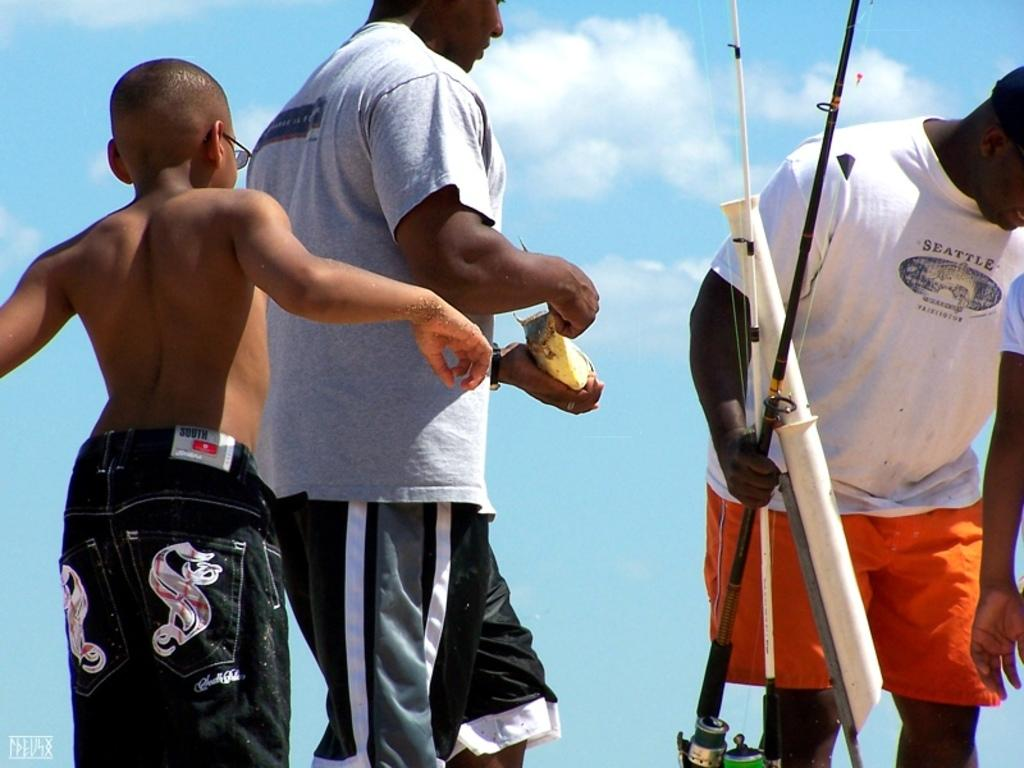How many people are in the image? There are three persons in the image. What is the man on the right side doing? The man on the right side is holding something. What can be seen in the background of the image? The sky is visible in the background of the image. What type of list can be seen on the gate in the image? There is no gate or list present in the image. What kind of blade is being used by the person on the left side of the image? There is no blade visible in the image, and there is only one person mentioned in the facts. 